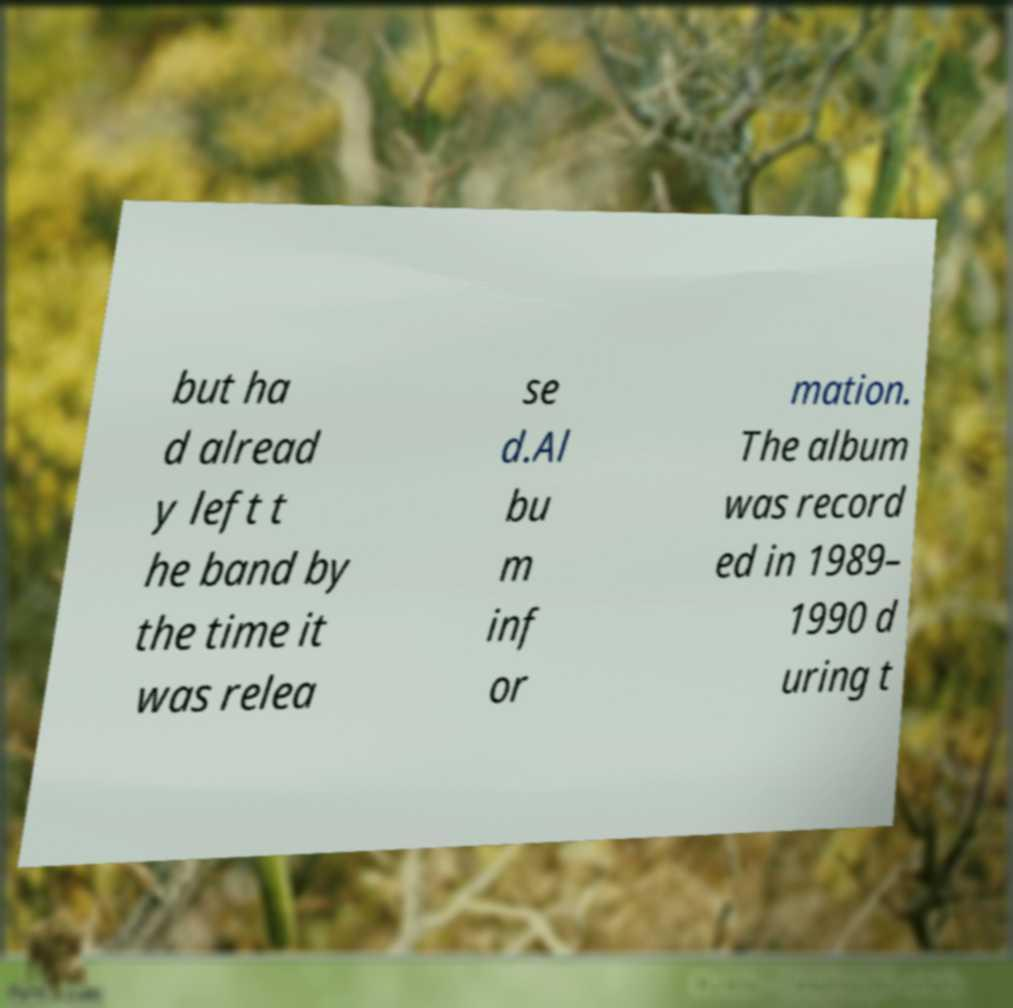For documentation purposes, I need the text within this image transcribed. Could you provide that? but ha d alread y left t he band by the time it was relea se d.Al bu m inf or mation. The album was record ed in 1989– 1990 d uring t 